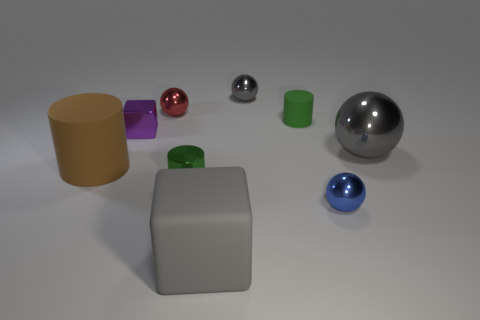Subtract all big gray spheres. How many spheres are left? 3 Subtract all gray balls. How many balls are left? 2 Subtract all cylinders. How many objects are left? 6 Subtract 2 blocks. How many blocks are left? 0 Add 1 brown objects. How many brown objects exist? 2 Add 1 tiny gray metallic balls. How many objects exist? 10 Subtract 1 purple cubes. How many objects are left? 8 Subtract all green balls. Subtract all green cubes. How many balls are left? 4 Subtract all gray balls. How many green cylinders are left? 2 Subtract all matte cubes. Subtract all cubes. How many objects are left? 6 